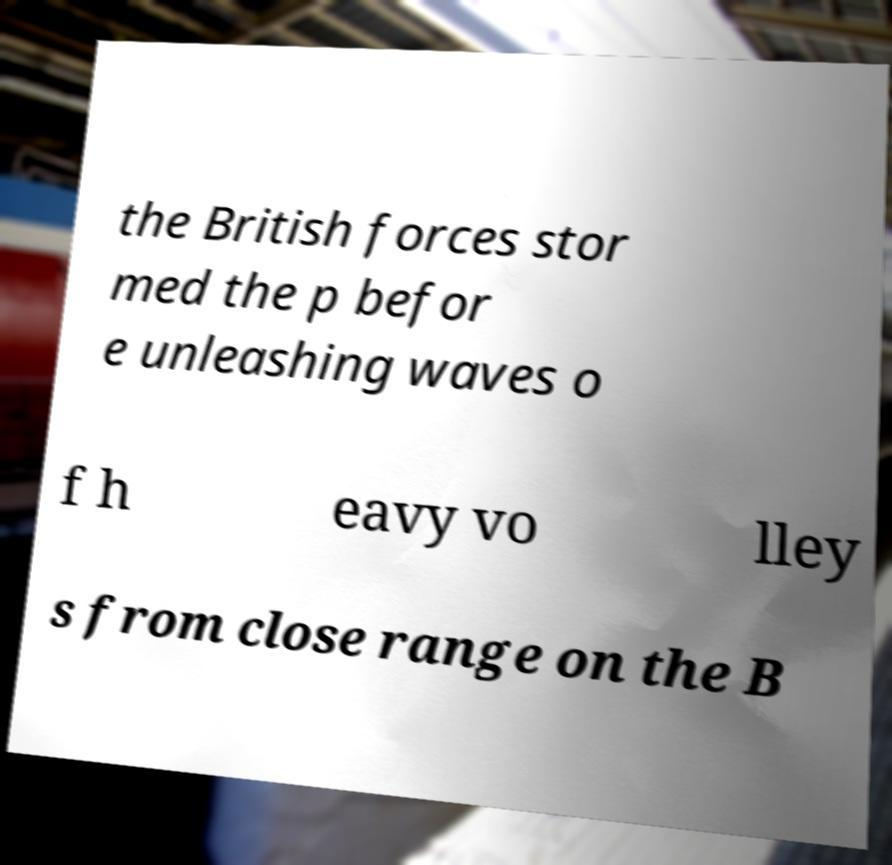For documentation purposes, I need the text within this image transcribed. Could you provide that? the British forces stor med the p befor e unleashing waves o f h eavy vo lley s from close range on the B 